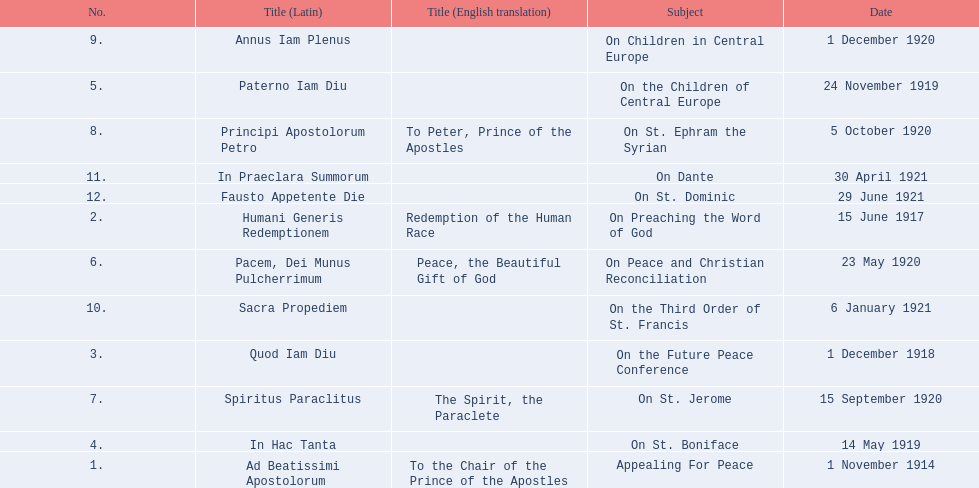What is the dates of the list of encyclicals of pope benedict xv? 1 November 1914, 15 June 1917, 1 December 1918, 14 May 1919, 24 November 1919, 23 May 1920, 15 September 1920, 5 October 1920, 1 December 1920, 6 January 1921, 30 April 1921, 29 June 1921. Of these dates, which subject was on 23 may 1920? On Peace and Christian Reconciliation. Give me the full table as a dictionary. {'header': ['No.', 'Title (Latin)', 'Title (English translation)', 'Subject', 'Date'], 'rows': [['9.', 'Annus Iam Plenus', '', 'On Children in Central Europe', '1 December 1920'], ['5.', 'Paterno Iam Diu', '', 'On the Children of Central Europe', '24 November 1919'], ['8.', 'Principi Apostolorum Petro', 'To Peter, Prince of the Apostles', 'On St. Ephram the Syrian', '5 October 1920'], ['11.', 'In Praeclara Summorum', '', 'On Dante', '30 April 1921'], ['12.', 'Fausto Appetente Die', '', 'On St. Dominic', '29 June 1921'], ['2.', 'Humani Generis Redemptionem', 'Redemption of the Human Race', 'On Preaching the Word of God', '15 June 1917'], ['6.', 'Pacem, Dei Munus Pulcherrimum', 'Peace, the Beautiful Gift of God', 'On Peace and Christian Reconciliation', '23 May 1920'], ['10.', 'Sacra Propediem', '', 'On the Third Order of St. Francis', '6 January 1921'], ['3.', 'Quod Iam Diu', '', 'On the Future Peace Conference', '1 December 1918'], ['7.', 'Spiritus Paraclitus', 'The Spirit, the Paraclete', 'On St. Jerome', '15 September 1920'], ['4.', 'In Hac Tanta', '', 'On St. Boniface', '14 May 1919'], ['1.', 'Ad Beatissimi Apostolorum', 'To the Chair of the Prince of the Apostles', 'Appealing For Peace', '1 November 1914']]} 